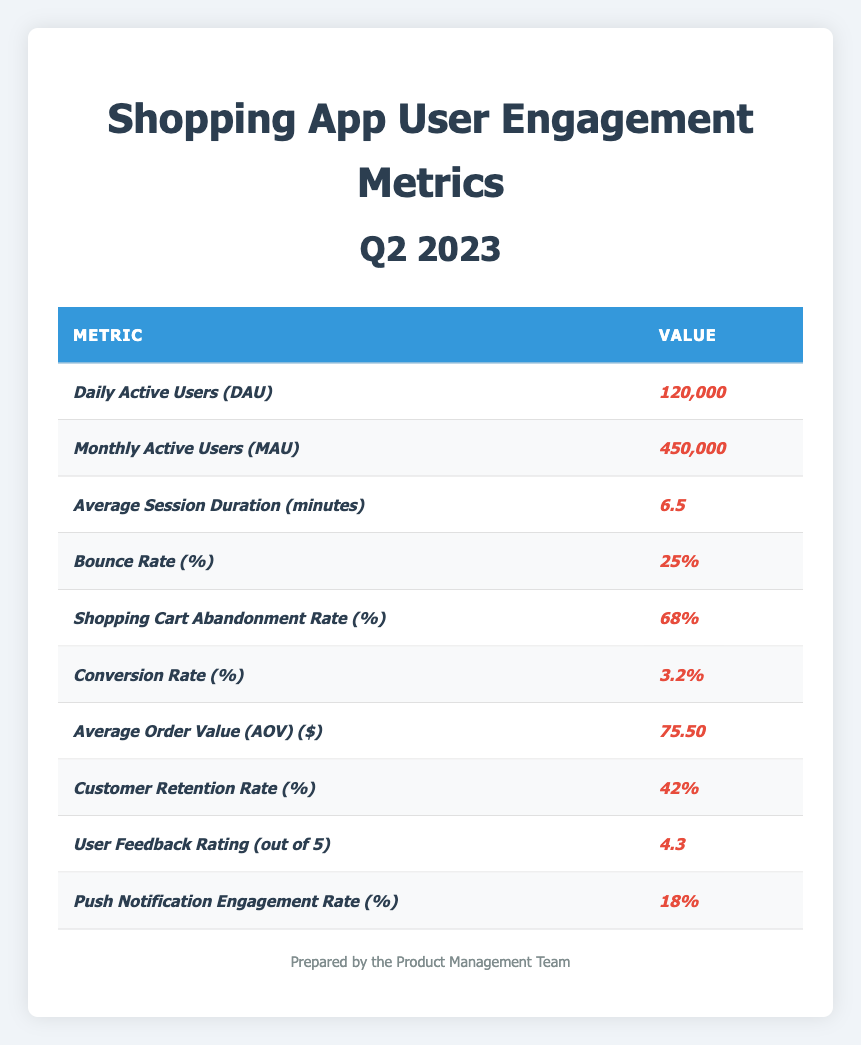What is the value of Daily Active Users (DAU)? The table lists the Daily Active Users (DAU) with a value of 120,000.
Answer: 120,000 What is the Monthly Active Users (MAU) count? The table specifies that the Monthly Active Users (MAU) is 450,000.
Answer: 450,000 What is the average session duration in minutes? According to the table, the average session duration is 6.5 minutes.
Answer: 6.5 What is the Bounce Rate? The table shows the Bounce Rate as 25%.
Answer: 25% Is the Shopping Cart Abandonment Rate higher than 50%? The table states the Shopping Cart Abandonment Rate is 68%, which is indeed higher than 50%.
Answer: Yes What is the Conversion Rate? The table indicates that the Conversion Rate is 3.2%.
Answer: 3.2% What is the Average Order Value (AOV) in dollars? The Average Order Value (AOV) as per the table is $75.50.
Answer: 75.50 What is the Customer Retention Rate? The Customer Retention Rate listed in the table is 42%.
Answer: 42% How would you describe the User Feedback Rating out of 5? The table indicates a User Feedback Rating of 4.3 out of 5.
Answer: 4.3 What is the Push Notification Engagement Rate? The Push Notification Engagement Rate is stated in the table as 18%.
Answer: 18% If we compare the Conversion Rate and the Bounce Rate, which is higher? The Bounce Rate is 25% while the Conversion Rate is 3.2%. Since 25% is higher than 3.2%, the Bounce Rate is higher.
Answer: Bounce Rate What is the total number of users (DAU + MAU) in the given metrics? The Daily Active Users (DAU) is 120,000 and the Monthly Active Users (MAU) is 450,000. Therefore, the total is 120,000 + 450,000 = 570,000.
Answer: 570,000 What is the difference between the Shopping Cart Abandonment Rate and the Conversion Rate? The Shopping Cart Abandonment Rate is 68%, and the Conversion Rate is 3.2%. Calculating the difference gives 68% - 3.2% = 64.8%.
Answer: 64.8% What percentage of users engage with push notifications relative to MAU? Push Notification Engagement Rate is 18%, and the Monthly Active Users (MAU) is 450,000. Thus, if we calculate the engaged users, it is 450,000 * (18/100) = 81,000 engaged users.
Answer: 81,000 Is the User Feedback Rating above 4? The User Feedback Rating is 4.3, which is indeed above 4.
Answer: Yes Considering the Average Order Value (AOV) and Conversion Rate, what might that imply about shopping behavior? The Average Order Value (AOV) of $75.50 combined with a Conversion Rate of 3.2% suggests that while a relatively low percentage of users are converting, the value of each transaction is notable, indicating potential for growth by improving conversion mechanisms.
Answer: Potential for growth 